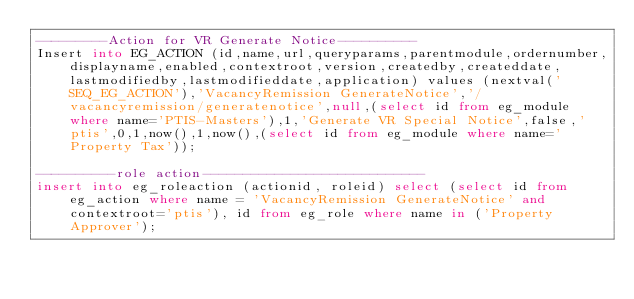Convert code to text. <code><loc_0><loc_0><loc_500><loc_500><_SQL_>---------Action for VR Generate Notice----------
Insert into EG_ACTION (id,name,url,queryparams,parentmodule,ordernumber,displayname,enabled,contextroot,version,createdby,createddate,lastmodifiedby,lastmodifieddate,application) values (nextval('SEQ_EG_ACTION'),'VacancyRemission GenerateNotice','/vacancyremission/generatenotice',null,(select id from eg_module where name='PTIS-Masters'),1,'Generate VR Special Notice',false,'ptis',0,1,now(),1,now(),(select id from eg_module where name='Property Tax'));

----------role action----------------------------
insert into eg_roleaction (actionid, roleid) select (select id from eg_action where name = 'VacancyRemission GenerateNotice' and contextroot='ptis'), id from eg_role where name in ('Property Approver');
</code> 